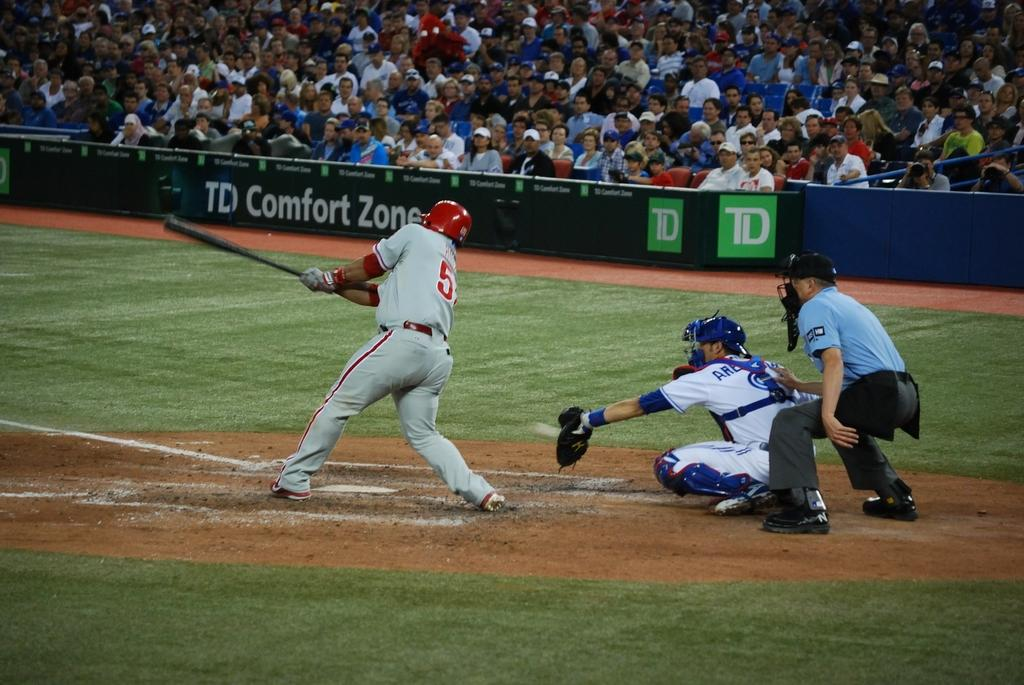<image>
Give a short and clear explanation of the subsequent image. A batter takes a swing as people watch behind a TD Comfort Zone banner. 